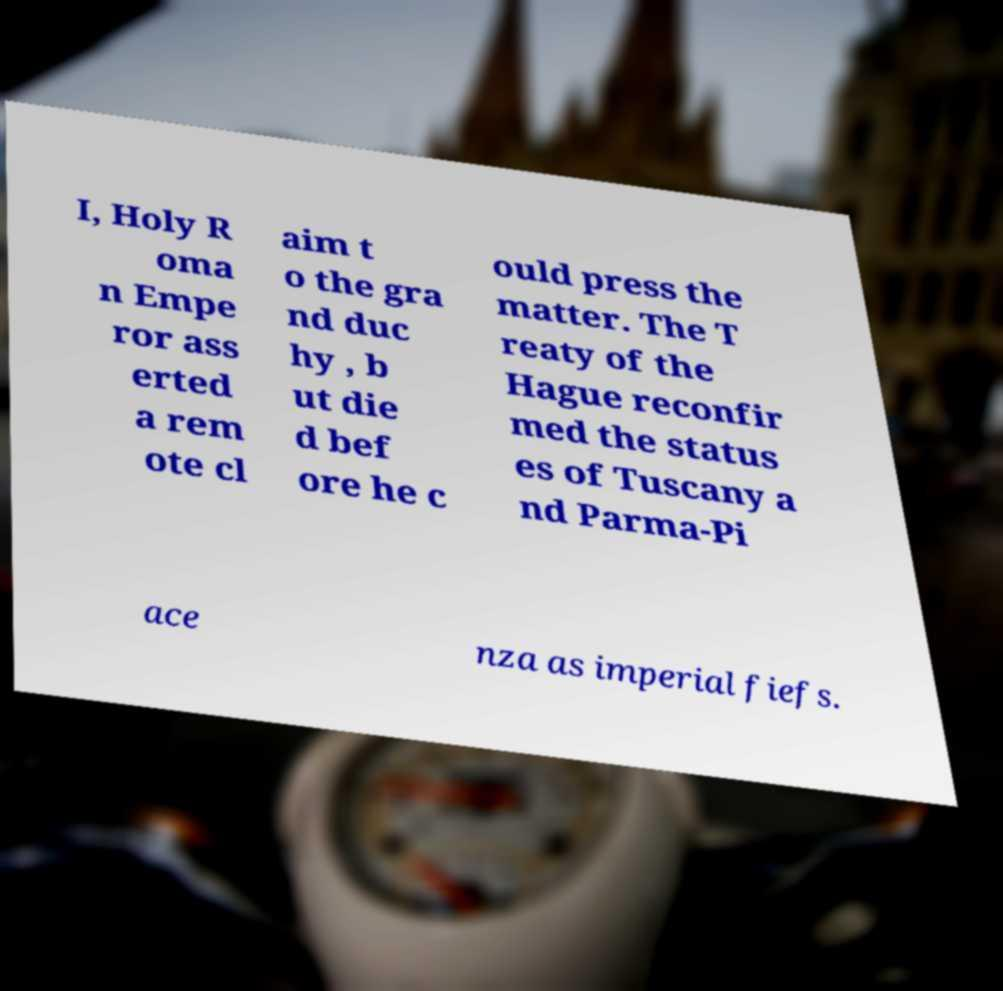What messages or text are displayed in this image? I need them in a readable, typed format. I, Holy R oma n Empe ror ass erted a rem ote cl aim t o the gra nd duc hy , b ut die d bef ore he c ould press the matter. The T reaty of the Hague reconfir med the status es of Tuscany a nd Parma-Pi ace nza as imperial fiefs. 